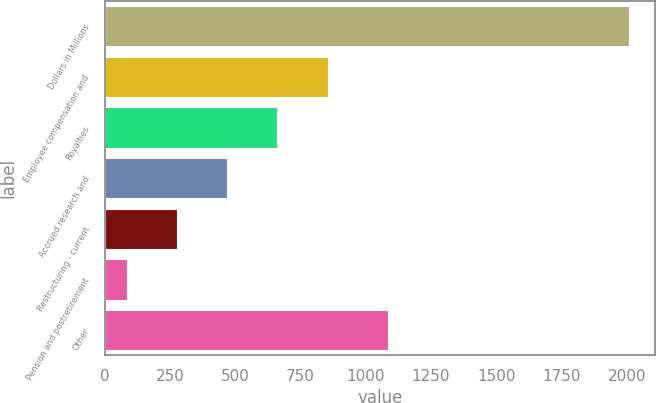Convert chart. <chart><loc_0><loc_0><loc_500><loc_500><bar_chart><fcel>Dollars in Millions<fcel>Employee compensation and<fcel>Royalties<fcel>Accrued research and<fcel>Restructuring - current<fcel>Pension and postretirement<fcel>Other<nl><fcel>2007<fcel>853.8<fcel>661.6<fcel>469.4<fcel>277.2<fcel>85<fcel>1086<nl></chart> 